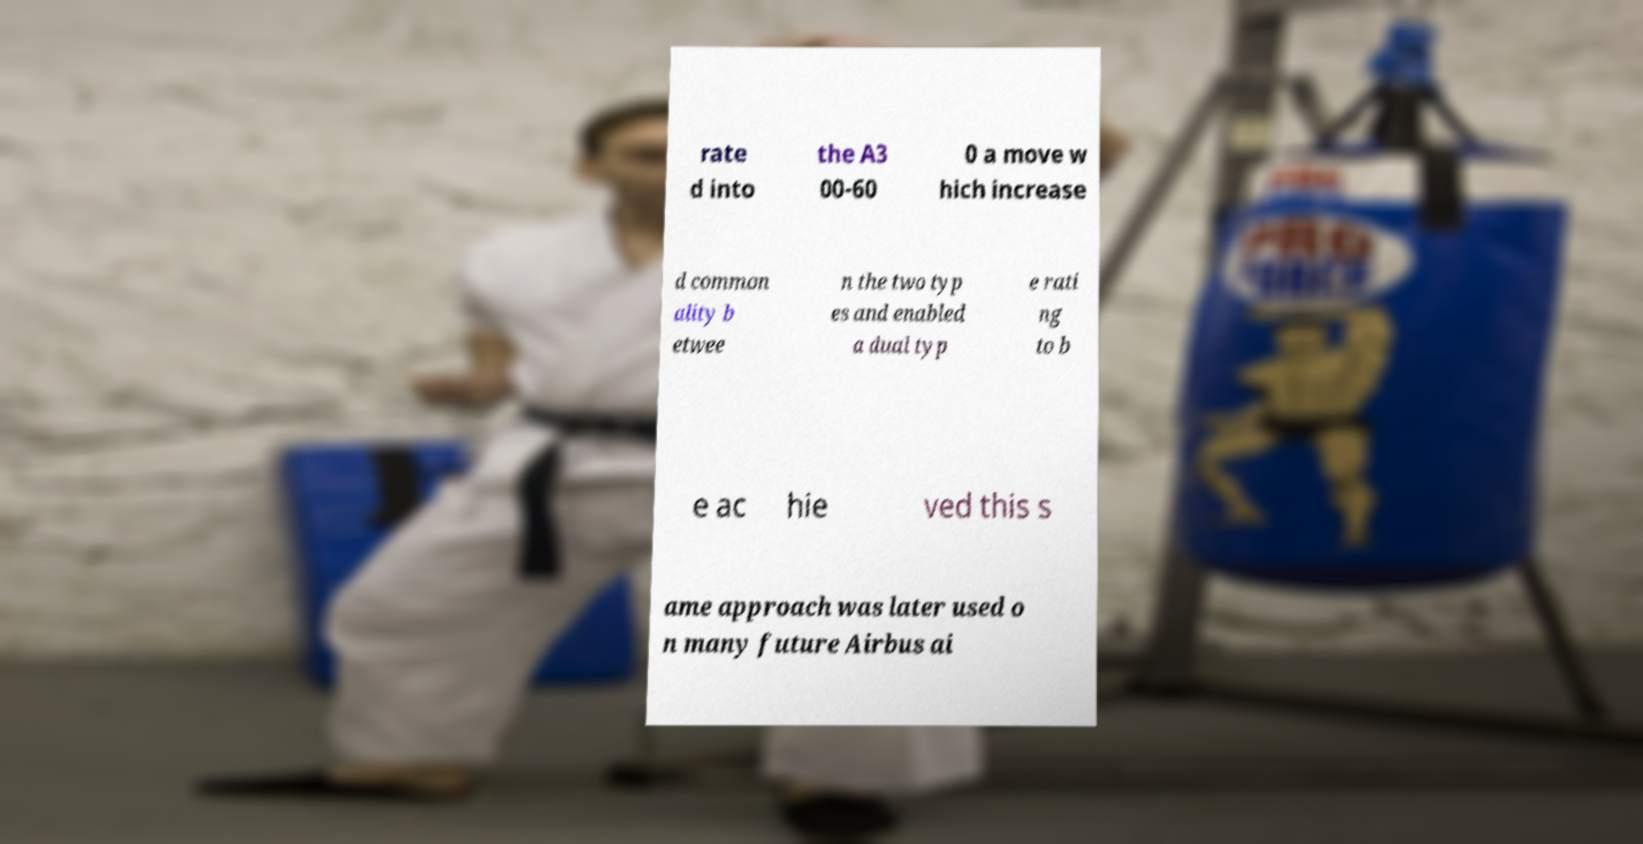Could you assist in decoding the text presented in this image and type it out clearly? rate d into the A3 00-60 0 a move w hich increase d common ality b etwee n the two typ es and enabled a dual typ e rati ng to b e ac hie ved this s ame approach was later used o n many future Airbus ai 